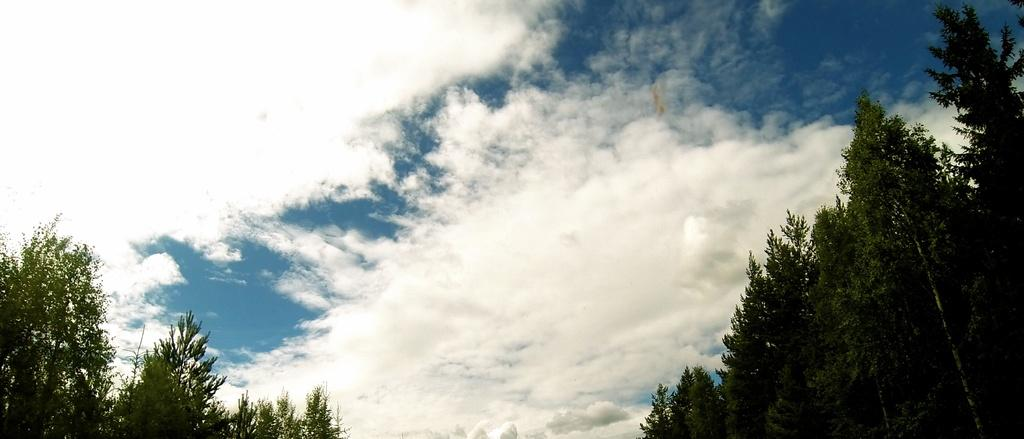What is visible in the background of the image? The sky is visible in the image. What can be seen in the sky? There are clouds in the sky. What type of vegetation is present in the image? There are trees in the image. How many jellyfish can be seen swimming in the sky in the image? There are no jellyfish present in the image; it features the sky with clouds and trees. What type of animal is grazing among the trees in the image? There is no animal, such as a zebra, present among the trees in the image. 